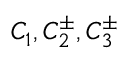<formula> <loc_0><loc_0><loc_500><loc_500>C _ { 1 } , C _ { 2 } ^ { \pm } , C _ { 3 } ^ { \pm }</formula> 